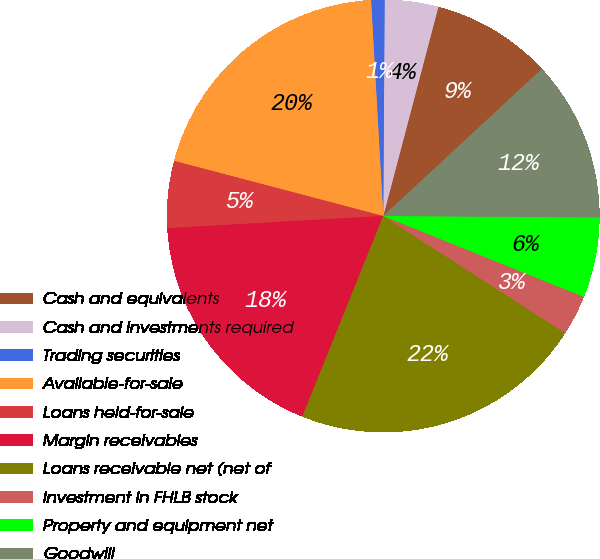Convert chart. <chart><loc_0><loc_0><loc_500><loc_500><pie_chart><fcel>Cash and equivalents<fcel>Cash and investments required<fcel>Trading securities<fcel>Available-for-sale<fcel>Loans held-for-sale<fcel>Margin receivables<fcel>Loans receivable net (net of<fcel>Investment in FHLB stock<fcel>Property and equipment net<fcel>Goodwill<nl><fcel>9.0%<fcel>4.0%<fcel>1.0%<fcel>20.0%<fcel>5.0%<fcel>18.0%<fcel>22.0%<fcel>3.0%<fcel>6.0%<fcel>12.0%<nl></chart> 